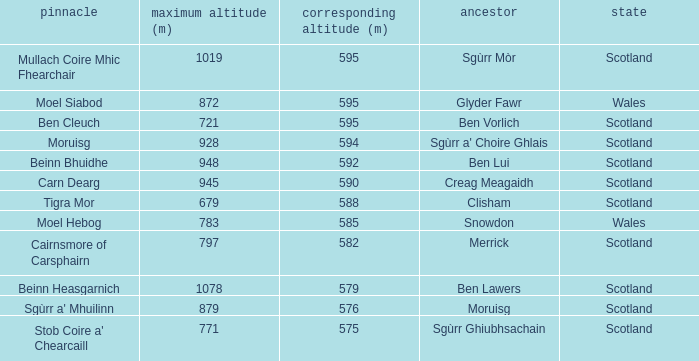What is the relative height of Scotland with Ben Vorlich as parent? 1.0. 